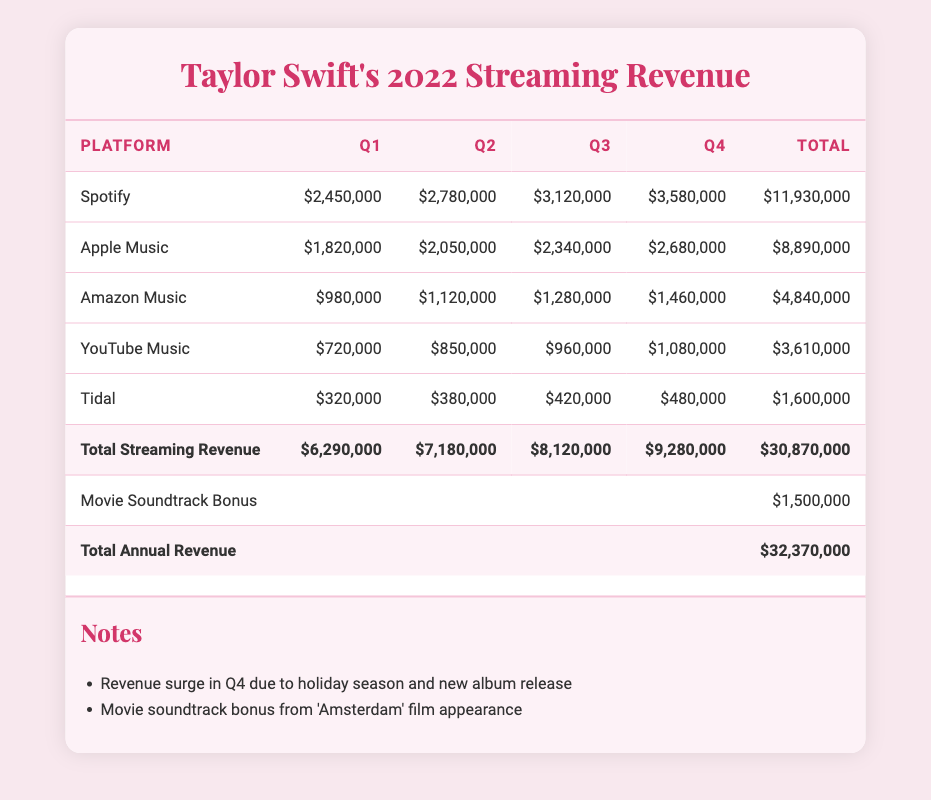What was the total revenue from Spotify in 2022? To find the total revenue from Spotify, we add the quarterly revenues from Q1 to Q4: 2,450,000 + 2,780,000 + 3,120,000 + 3,580,000 = 11,930,000.
Answer: 11,930,000 Which platform generated the least revenue in Q2? Looking at the Q2 revenues across all platforms, they are: Spotify 2,780,000, Apple Music 2,050,000, Amazon Music 1,120,000, YouTube Music 850,000, and Tidal 380,000. The smallest value is Tidal at 380,000.
Answer: Tidal What is the percentage increase in revenue from Q1 to Q4 for Apple Music? The revenue for Apple Music in Q1 is 1,820,000 and in Q4 is 2,680,000. The increase is 2,680,000 - 1,820,000 = 860,000. The percentage increase is (860,000 / 1,820,000) * 100 ≈ 47.28%.
Answer: Approximately 47.28% Is the total annual revenue from streaming platforms greater than 30 million? The total annual revenue from streaming platforms is listed as 32,370,000, which is greater than 30 million.
Answer: Yes What is the average quarterly revenue from all platforms in Q3? To calculate the average Q3 revenue, we first add up the revenues for Q3: 3,120,000 (Spotify) + 2,340,000 (Apple Music) + 1,280,000 (Amazon Music) + 960,000 (YouTube Music) + 420,000 (Tidal) = 8,120,000. Then, divide this sum by the number of platforms (5): 8,120,000 / 5 = 1,624,000.
Answer: 1,624,000 What was the total revenue from all platforms in Q4? The Q4 revenues for the platforms are as follows: Spotify 3,580,000, Apple Music 2,680,000, Amazon Music 1,460,000, YouTube Music 1,080,000, and Tidal 480,000. The total is calculated as: 3,580,000 + 2,680,000 + 1,460,000 + 1,080,000 + 480,000 = 9,280,000.
Answer: 9,280,000 How much revenue did Amazon Music earn in total for the year compared to YouTube Music? The total revenue for Amazon Music is 4,840,000, and for YouTube Music, it is 3,610,000. When comparing, Amazon Music earned more: 4,840,000 > 3,610,000.
Answer: Amazon Music earned more What are the combined revenues of the top two streaming platforms in Q1? The top two platforms by Q1 revenue are Spotify with 2,450,000 and Apple Music with 1,820,000. Their combined revenue is 2,450,000 + 1,820,000 = 4,270,000.
Answer: 4,270,000 What notable fact is mentioned about the revenue in Q4? The table includes a note indicating that there was a revenue surge in Q4 due to the holiday season and the release of a new album.
Answer: Revenue surge due to holiday season and new album release 